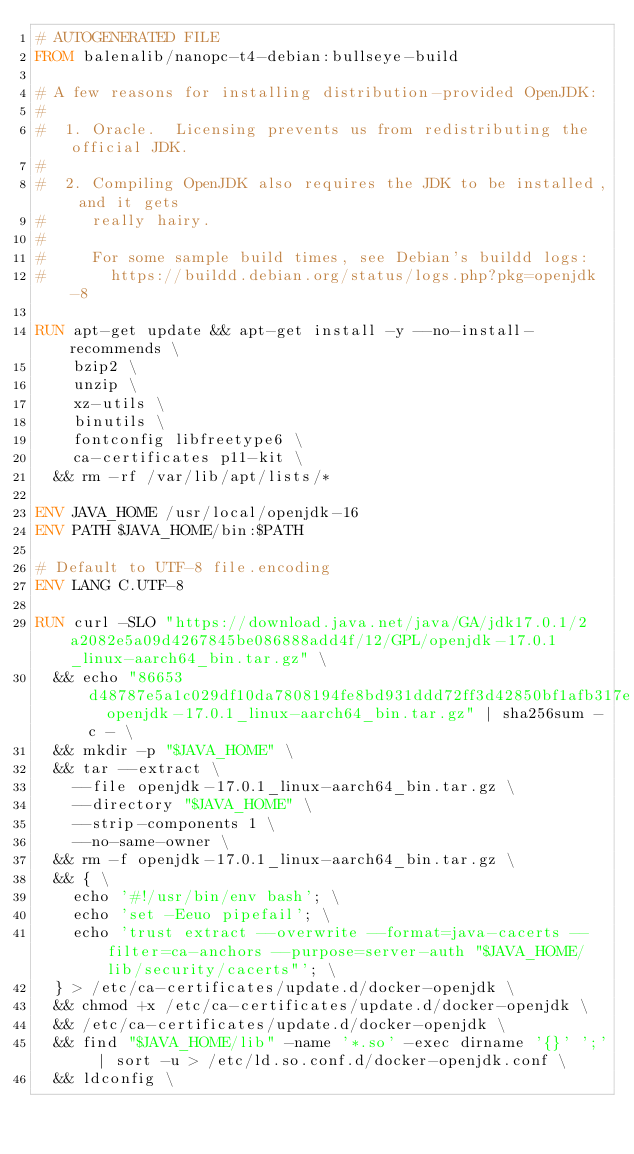Convert code to text. <code><loc_0><loc_0><loc_500><loc_500><_Dockerfile_># AUTOGENERATED FILE
FROM balenalib/nanopc-t4-debian:bullseye-build

# A few reasons for installing distribution-provided OpenJDK:
#
#  1. Oracle.  Licensing prevents us from redistributing the official JDK.
#
#  2. Compiling OpenJDK also requires the JDK to be installed, and it gets
#     really hairy.
#
#     For some sample build times, see Debian's buildd logs:
#       https://buildd.debian.org/status/logs.php?pkg=openjdk-8

RUN apt-get update && apt-get install -y --no-install-recommends \
		bzip2 \
		unzip \
		xz-utils \
		binutils \
		fontconfig libfreetype6 \
		ca-certificates p11-kit \
	&& rm -rf /var/lib/apt/lists/*

ENV JAVA_HOME /usr/local/openjdk-16
ENV PATH $JAVA_HOME/bin:$PATH

# Default to UTF-8 file.encoding
ENV LANG C.UTF-8

RUN curl -SLO "https://download.java.net/java/GA/jdk17.0.1/2a2082e5a09d4267845be086888add4f/12/GPL/openjdk-17.0.1_linux-aarch64_bin.tar.gz" \
	&& echo "86653d48787e5a1c029df10da7808194fe8bd931ddd72ff3d42850bf1afb317e  openjdk-17.0.1_linux-aarch64_bin.tar.gz" | sha256sum -c - \
	&& mkdir -p "$JAVA_HOME" \
	&& tar --extract \
		--file openjdk-17.0.1_linux-aarch64_bin.tar.gz \
		--directory "$JAVA_HOME" \
		--strip-components 1 \
		--no-same-owner \
	&& rm -f openjdk-17.0.1_linux-aarch64_bin.tar.gz \
	&& { \
		echo '#!/usr/bin/env bash'; \
		echo 'set -Eeuo pipefail'; \
		echo 'trust extract --overwrite --format=java-cacerts --filter=ca-anchors --purpose=server-auth "$JAVA_HOME/lib/security/cacerts"'; \
	} > /etc/ca-certificates/update.d/docker-openjdk \
	&& chmod +x /etc/ca-certificates/update.d/docker-openjdk \
	&& /etc/ca-certificates/update.d/docker-openjdk \
	&& find "$JAVA_HOME/lib" -name '*.so' -exec dirname '{}' ';' | sort -u > /etc/ld.so.conf.d/docker-openjdk.conf \
	&& ldconfig \</code> 